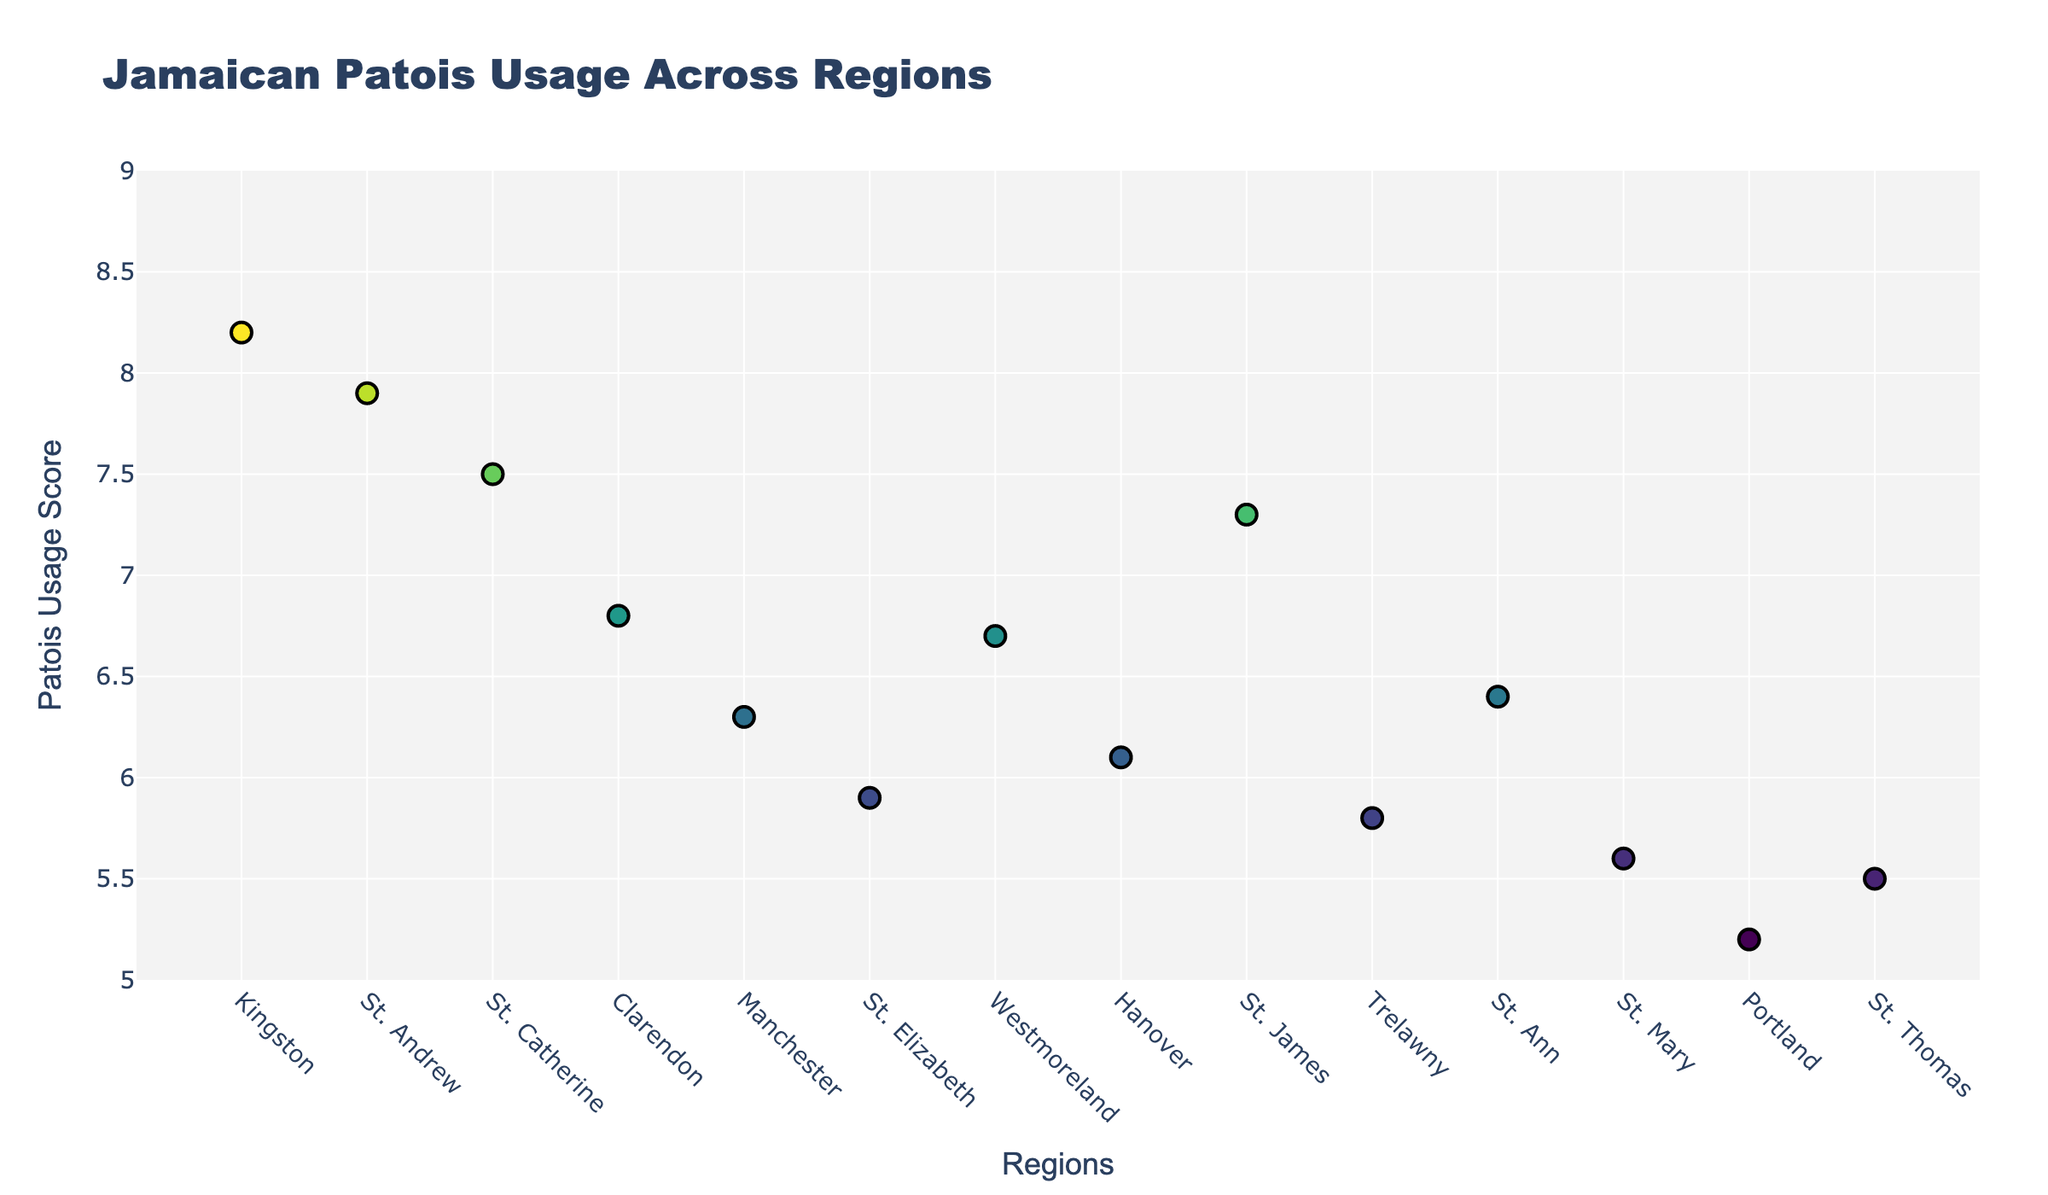How many data points are represented in the plot? The x-axis titled "Regions" lists various regions of Jamaica, each corresponding to a data point on the plot. By counting these, we can determine the number of data points.
Answer: 14 Which region shows the highest usage of Jamaican Patois? By examining the y-axis titled "Patois Usage Score" and looking for the highest value, we can identify the corresponding region. Kingston has the highest value of 8.2.
Answer: Kingston What is the Patois Usage Score range for all regions? The y-axis range is explicitly set from 5 to 9, and the data points range from a minimum score of 5.2 (Portland) to a maximum of 8.2 (Kingston). Thus, the range in the plot is from 5.2 to 8.2.
Answer: 5.2 to 8.2 Which region has the lowest Patois Usage Score? By locating the lowest point on the y-axis (which is approximately 5.2 for Portland), the corresponding region can be identified.
Answer: Portland What is the average Patois Usage Score across all regions? Add up all the usage scores (8.2 + 7.9 + 7.5 + 6.8 + 6.3 + 5.9 + 6.7 + 6.1 + 7.3 + 5.8 + 6.4 + 5.6 + 5.2 + 5.5), then divide by the number of regions (14). The total is 91.2, and the average is 91.2 / 14 = 6.51.
Answer: 6.51 Which regions have a Patois Usage Score greater than 7.0? Look for data points above 7.0 on the y-axis and check the corresponding regions on the x-axis. The regions are Kingston, St. Andrew, St. Catherine, and St. James.
Answer: Kingston, St. Andrew, St. Catherine, St. James How many regions have a Patois Usage Score between 5.5 and 6.5? Identify points on the y-axis within the range of 5.5 to 6.5 and count their occurrences. They are found at the positions of Clarendon, Manchester, St. Elizabeth, Hanover, Trelawny, St. Ann, St. Mary, and St. Thomas, totaling 8 regions.
Answer: 8 Which region is positioned next to Kingston (Position 1) and what is its Patois Usage Score? According to the x-axis, the next region after Kingston (Position 1) is St. Andrew (Position 2). The Patois Usage Score for St. Andrew is 7.9.
Answer: St. Andrew, 7.9 Is there any region with a Patois Usage Score of exactly 6.0? Examine each data point on the y-axis to check if any score is exactly 6.0. There is no such point; hence, no region has a score of exactly 6.0.
Answer: No What is the difference in Patois Usage Score between Kingston and Portland? Subtract the Patois Usage Score of Portland from that of Kingston (8.2 - 5.2). The difference is 3.0.
Answer: 3.0 